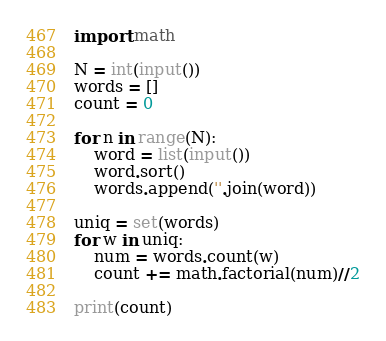<code> <loc_0><loc_0><loc_500><loc_500><_Python_>import math

N = int(input())
words = []
count = 0

for n in range(N):
    word = list(input())
    word.sort()
    words.append(''.join(word))

uniq = set(words)
for w in uniq:
    num = words.count(w)
    count += math.factorial(num)//2

print(count)</code> 